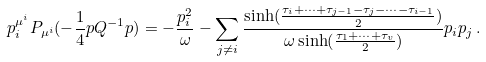Convert formula to latex. <formula><loc_0><loc_0><loc_500><loc_500>p _ { i } ^ { \mu ^ { i } } P _ { \mu ^ { i } } ( - \frac { 1 } { 4 } p Q ^ { - 1 } p ) & = - \frac { p _ { i } ^ { 2 } } { \omega } - \sum _ { j \neq i } \frac { \sinh ( \frac { \tau _ { i } + \dots + \tau _ { j - 1 } - \tau _ { j } - \dots - \tau _ { i - 1 } } { 2 } ) } { \omega \sinh ( \frac { \tau _ { 1 } + \dots + \tau _ { v } } { 2 } ) } p _ { i } p _ { j } \, .</formula> 